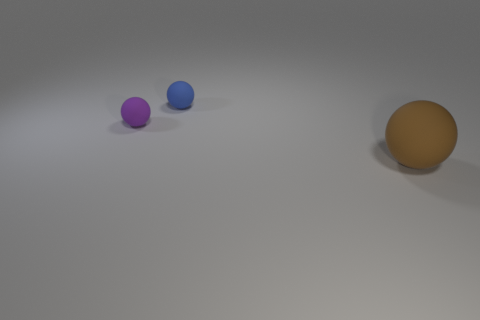How many tiny rubber things are to the left of the matte thing in front of the small rubber object that is on the left side of the blue sphere?
Offer a terse response. 2. How many objects are big brown rubber balls or objects left of the big brown rubber thing?
Provide a succinct answer. 3. Is the number of purple things behind the big object greater than the number of red rubber balls?
Your answer should be very brief. Yes. Are there the same number of big brown rubber balls that are on the left side of the large brown matte thing and blue spheres behind the purple object?
Provide a short and direct response. No. There is a sphere that is to the right of the small blue object; are there any small things on the left side of it?
Give a very brief answer. Yes. What shape is the tiny purple matte thing?
Keep it short and to the point. Sphere. There is a rubber thing left of the tiny thing that is behind the small purple object; what size is it?
Offer a very short reply. Small. There is a brown rubber object that is on the right side of the purple ball; what size is it?
Offer a very short reply. Large. Is the number of purple rubber spheres on the right side of the blue rubber ball less than the number of things to the right of the large ball?
Your response must be concise. No. The big rubber ball is what color?
Make the answer very short. Brown. 